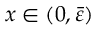Convert formula to latex. <formula><loc_0><loc_0><loc_500><loc_500>x \in ( 0 , \bar { \varepsilon } )</formula> 